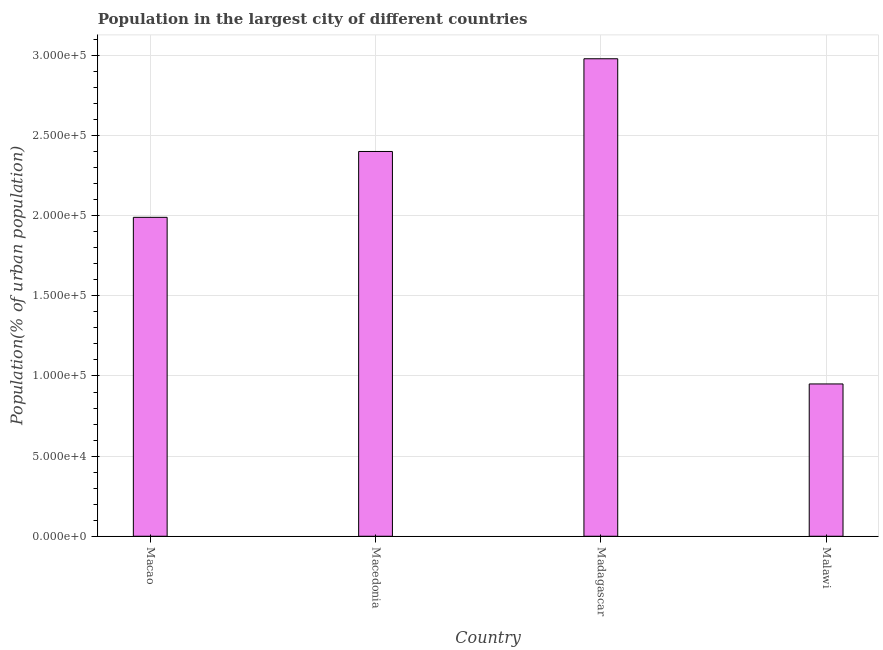What is the title of the graph?
Offer a very short reply. Population in the largest city of different countries. What is the label or title of the X-axis?
Your response must be concise. Country. What is the label or title of the Y-axis?
Provide a succinct answer. Population(% of urban population). What is the population in largest city in Macao?
Your answer should be very brief. 1.99e+05. Across all countries, what is the maximum population in largest city?
Give a very brief answer. 2.98e+05. Across all countries, what is the minimum population in largest city?
Offer a terse response. 9.50e+04. In which country was the population in largest city maximum?
Your answer should be compact. Madagascar. In which country was the population in largest city minimum?
Offer a very short reply. Malawi. What is the sum of the population in largest city?
Provide a succinct answer. 8.32e+05. What is the difference between the population in largest city in Macao and Malawi?
Offer a terse response. 1.04e+05. What is the average population in largest city per country?
Make the answer very short. 2.08e+05. What is the median population in largest city?
Make the answer very short. 2.20e+05. What is the ratio of the population in largest city in Macedonia to that in Malawi?
Your answer should be very brief. 2.53. Is the population in largest city in Macedonia less than that in Madagascar?
Your answer should be compact. Yes. Is the difference between the population in largest city in Macedonia and Malawi greater than the difference between any two countries?
Keep it short and to the point. No. What is the difference between the highest and the second highest population in largest city?
Provide a succinct answer. 5.79e+04. Is the sum of the population in largest city in Madagascar and Malawi greater than the maximum population in largest city across all countries?
Provide a short and direct response. Yes. What is the difference between the highest and the lowest population in largest city?
Offer a very short reply. 2.03e+05. In how many countries, is the population in largest city greater than the average population in largest city taken over all countries?
Provide a short and direct response. 2. How many bars are there?
Ensure brevity in your answer.  4. Are the values on the major ticks of Y-axis written in scientific E-notation?
Keep it short and to the point. Yes. What is the Population(% of urban population) of Macao?
Keep it short and to the point. 1.99e+05. What is the Population(% of urban population) of Macedonia?
Your response must be concise. 2.40e+05. What is the Population(% of urban population) of Madagascar?
Keep it short and to the point. 2.98e+05. What is the Population(% of urban population) of Malawi?
Offer a very short reply. 9.50e+04. What is the difference between the Population(% of urban population) in Macao and Macedonia?
Provide a succinct answer. -4.11e+04. What is the difference between the Population(% of urban population) in Macao and Madagascar?
Ensure brevity in your answer.  -9.90e+04. What is the difference between the Population(% of urban population) in Macao and Malawi?
Your answer should be compact. 1.04e+05. What is the difference between the Population(% of urban population) in Macedonia and Madagascar?
Your answer should be compact. -5.79e+04. What is the difference between the Population(% of urban population) in Macedonia and Malawi?
Offer a very short reply. 1.45e+05. What is the difference between the Population(% of urban population) in Madagascar and Malawi?
Provide a succinct answer. 2.03e+05. What is the ratio of the Population(% of urban population) in Macao to that in Macedonia?
Give a very brief answer. 0.83. What is the ratio of the Population(% of urban population) in Macao to that in Madagascar?
Offer a very short reply. 0.67. What is the ratio of the Population(% of urban population) in Macao to that in Malawi?
Offer a terse response. 2.09. What is the ratio of the Population(% of urban population) in Macedonia to that in Madagascar?
Your answer should be very brief. 0.81. What is the ratio of the Population(% of urban population) in Macedonia to that in Malawi?
Provide a short and direct response. 2.53. What is the ratio of the Population(% of urban population) in Madagascar to that in Malawi?
Give a very brief answer. 3.13. 